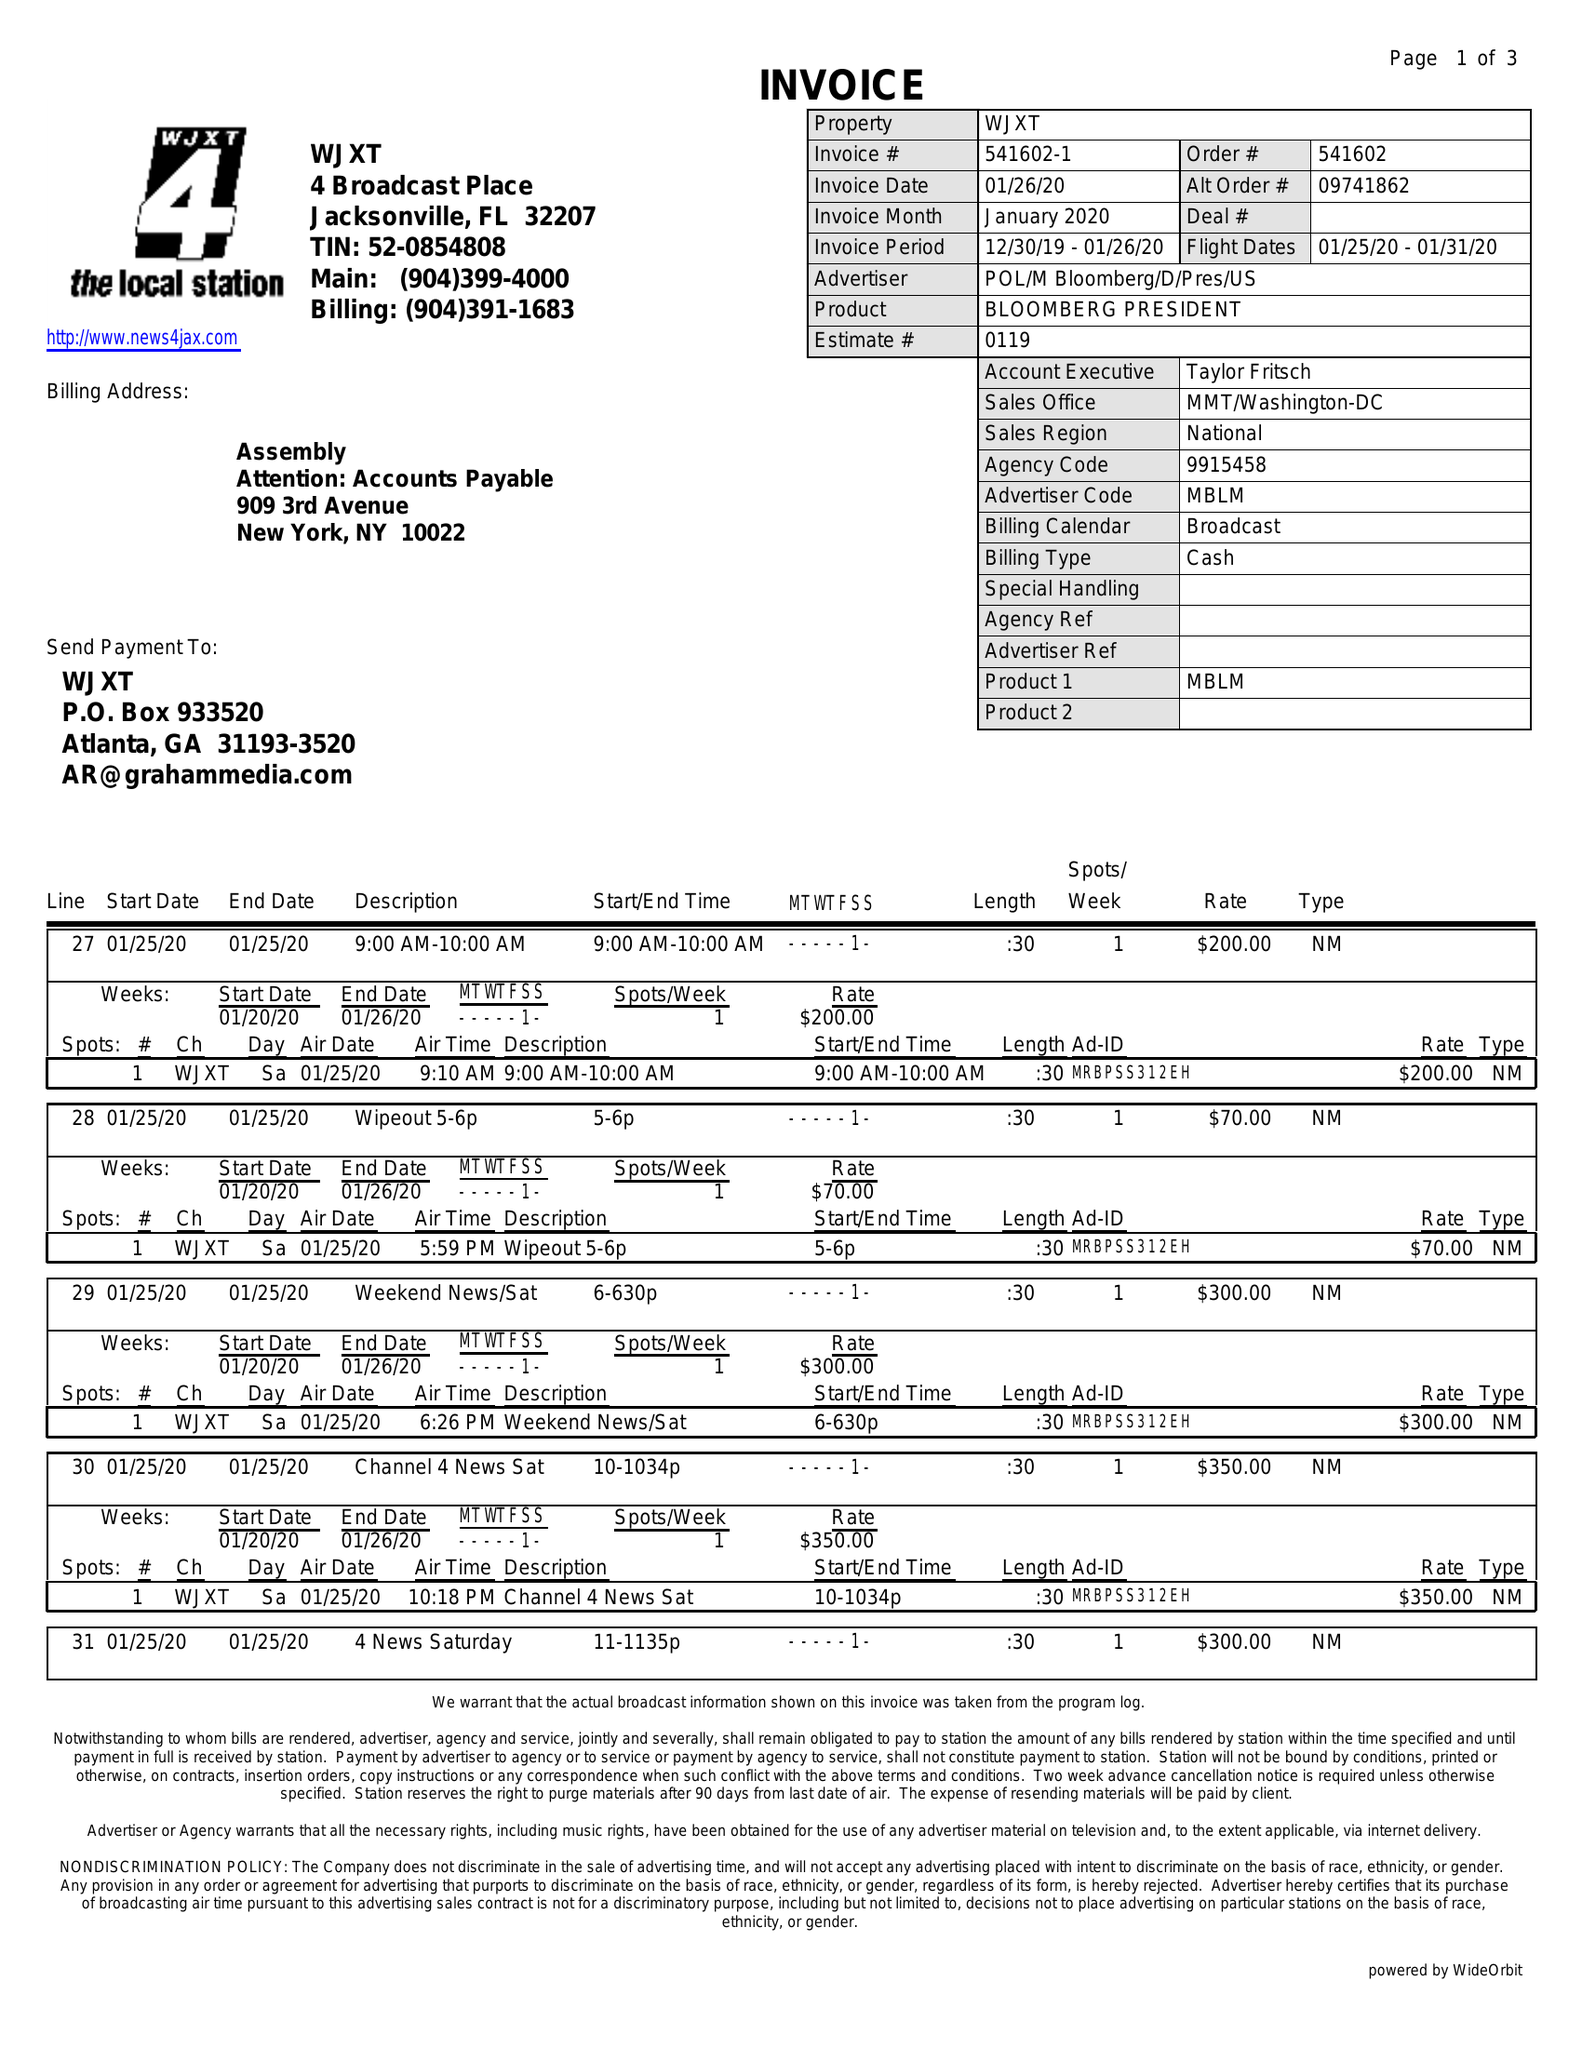What is the value for the flight_from?
Answer the question using a single word or phrase. 01/25/20 